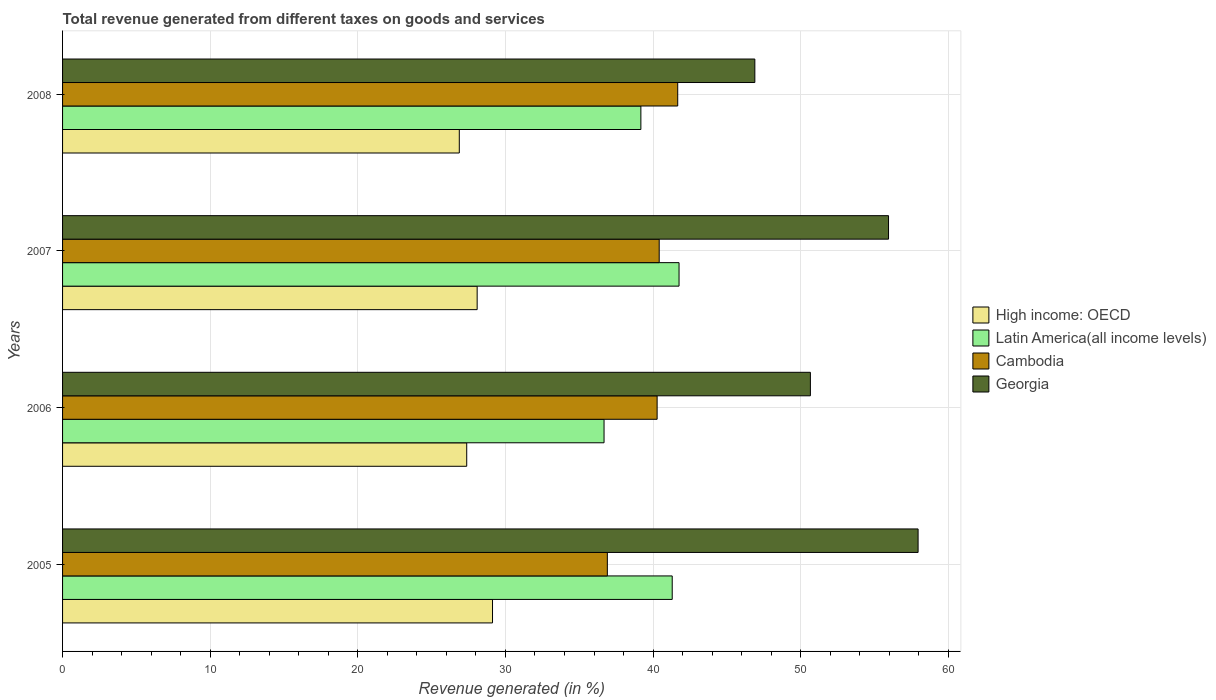How many groups of bars are there?
Provide a short and direct response. 4. Are the number of bars per tick equal to the number of legend labels?
Provide a short and direct response. Yes. Are the number of bars on each tick of the Y-axis equal?
Make the answer very short. Yes. How many bars are there on the 2nd tick from the top?
Offer a very short reply. 4. How many bars are there on the 4th tick from the bottom?
Offer a very short reply. 4. What is the total revenue generated in Latin America(all income levels) in 2007?
Make the answer very short. 41.76. Across all years, what is the maximum total revenue generated in Georgia?
Provide a succinct answer. 57.95. Across all years, what is the minimum total revenue generated in Latin America(all income levels)?
Your answer should be very brief. 36.68. In which year was the total revenue generated in Cambodia minimum?
Make the answer very short. 2005. What is the total total revenue generated in Latin America(all income levels) in the graph?
Make the answer very short. 158.91. What is the difference between the total revenue generated in Latin America(all income levels) in 2007 and that in 2008?
Your answer should be very brief. 2.59. What is the difference between the total revenue generated in Cambodia in 2006 and the total revenue generated in Latin America(all income levels) in 2005?
Provide a short and direct response. -1.02. What is the average total revenue generated in Latin America(all income levels) per year?
Ensure brevity in your answer.  39.73. In the year 2008, what is the difference between the total revenue generated in Georgia and total revenue generated in Cambodia?
Ensure brevity in your answer.  5.22. What is the ratio of the total revenue generated in High income: OECD in 2006 to that in 2007?
Provide a short and direct response. 0.97. Is the difference between the total revenue generated in Georgia in 2005 and 2006 greater than the difference between the total revenue generated in Cambodia in 2005 and 2006?
Give a very brief answer. Yes. What is the difference between the highest and the second highest total revenue generated in Cambodia?
Keep it short and to the point. 1.25. What is the difference between the highest and the lowest total revenue generated in High income: OECD?
Provide a succinct answer. 2.25. In how many years, is the total revenue generated in High income: OECD greater than the average total revenue generated in High income: OECD taken over all years?
Ensure brevity in your answer.  2. What does the 2nd bar from the top in 2006 represents?
Your answer should be compact. Cambodia. What does the 4th bar from the bottom in 2008 represents?
Your answer should be compact. Georgia. Are all the bars in the graph horizontal?
Give a very brief answer. Yes. Are the values on the major ticks of X-axis written in scientific E-notation?
Your answer should be very brief. No. Does the graph contain any zero values?
Ensure brevity in your answer.  No. Does the graph contain grids?
Your answer should be compact. Yes. How are the legend labels stacked?
Provide a succinct answer. Vertical. What is the title of the graph?
Provide a succinct answer. Total revenue generated from different taxes on goods and services. What is the label or title of the X-axis?
Offer a very short reply. Revenue generated (in %). What is the label or title of the Y-axis?
Provide a short and direct response. Years. What is the Revenue generated (in %) in High income: OECD in 2005?
Offer a terse response. 29.13. What is the Revenue generated (in %) in Latin America(all income levels) in 2005?
Give a very brief answer. 41.3. What is the Revenue generated (in %) in Cambodia in 2005?
Provide a succinct answer. 36.9. What is the Revenue generated (in %) in Georgia in 2005?
Offer a terse response. 57.95. What is the Revenue generated (in %) of High income: OECD in 2006?
Give a very brief answer. 27.38. What is the Revenue generated (in %) in Latin America(all income levels) in 2006?
Provide a succinct answer. 36.68. What is the Revenue generated (in %) in Cambodia in 2006?
Your response must be concise. 40.28. What is the Revenue generated (in %) of Georgia in 2006?
Give a very brief answer. 50.66. What is the Revenue generated (in %) of High income: OECD in 2007?
Make the answer very short. 28.08. What is the Revenue generated (in %) in Latin America(all income levels) in 2007?
Your answer should be compact. 41.76. What is the Revenue generated (in %) of Cambodia in 2007?
Ensure brevity in your answer.  40.42. What is the Revenue generated (in %) in Georgia in 2007?
Ensure brevity in your answer.  55.95. What is the Revenue generated (in %) in High income: OECD in 2008?
Ensure brevity in your answer.  26.87. What is the Revenue generated (in %) of Latin America(all income levels) in 2008?
Your response must be concise. 39.17. What is the Revenue generated (in %) in Cambodia in 2008?
Keep it short and to the point. 41.67. What is the Revenue generated (in %) in Georgia in 2008?
Ensure brevity in your answer.  46.89. Across all years, what is the maximum Revenue generated (in %) of High income: OECD?
Ensure brevity in your answer.  29.13. Across all years, what is the maximum Revenue generated (in %) in Latin America(all income levels)?
Provide a succinct answer. 41.76. Across all years, what is the maximum Revenue generated (in %) in Cambodia?
Keep it short and to the point. 41.67. Across all years, what is the maximum Revenue generated (in %) of Georgia?
Keep it short and to the point. 57.95. Across all years, what is the minimum Revenue generated (in %) in High income: OECD?
Keep it short and to the point. 26.87. Across all years, what is the minimum Revenue generated (in %) in Latin America(all income levels)?
Make the answer very short. 36.68. Across all years, what is the minimum Revenue generated (in %) in Cambodia?
Your answer should be compact. 36.9. Across all years, what is the minimum Revenue generated (in %) of Georgia?
Provide a short and direct response. 46.89. What is the total Revenue generated (in %) in High income: OECD in the graph?
Give a very brief answer. 111.46. What is the total Revenue generated (in %) in Latin America(all income levels) in the graph?
Your answer should be very brief. 158.91. What is the total Revenue generated (in %) of Cambodia in the graph?
Your answer should be compact. 159.27. What is the total Revenue generated (in %) of Georgia in the graph?
Offer a very short reply. 211.46. What is the difference between the Revenue generated (in %) of High income: OECD in 2005 and that in 2006?
Provide a short and direct response. 1.75. What is the difference between the Revenue generated (in %) in Latin America(all income levels) in 2005 and that in 2006?
Your answer should be very brief. 4.62. What is the difference between the Revenue generated (in %) of Cambodia in 2005 and that in 2006?
Ensure brevity in your answer.  -3.37. What is the difference between the Revenue generated (in %) in Georgia in 2005 and that in 2006?
Give a very brief answer. 7.3. What is the difference between the Revenue generated (in %) of High income: OECD in 2005 and that in 2007?
Ensure brevity in your answer.  1.04. What is the difference between the Revenue generated (in %) in Latin America(all income levels) in 2005 and that in 2007?
Offer a very short reply. -0.46. What is the difference between the Revenue generated (in %) of Cambodia in 2005 and that in 2007?
Ensure brevity in your answer.  -3.51. What is the difference between the Revenue generated (in %) in Georgia in 2005 and that in 2007?
Keep it short and to the point. 2. What is the difference between the Revenue generated (in %) of High income: OECD in 2005 and that in 2008?
Your answer should be very brief. 2.25. What is the difference between the Revenue generated (in %) in Latin America(all income levels) in 2005 and that in 2008?
Offer a very short reply. 2.12. What is the difference between the Revenue generated (in %) in Cambodia in 2005 and that in 2008?
Provide a short and direct response. -4.77. What is the difference between the Revenue generated (in %) of Georgia in 2005 and that in 2008?
Your answer should be compact. 11.06. What is the difference between the Revenue generated (in %) in High income: OECD in 2006 and that in 2007?
Your response must be concise. -0.71. What is the difference between the Revenue generated (in %) of Latin America(all income levels) in 2006 and that in 2007?
Ensure brevity in your answer.  -5.08. What is the difference between the Revenue generated (in %) of Cambodia in 2006 and that in 2007?
Keep it short and to the point. -0.14. What is the difference between the Revenue generated (in %) of Georgia in 2006 and that in 2007?
Ensure brevity in your answer.  -5.29. What is the difference between the Revenue generated (in %) in High income: OECD in 2006 and that in 2008?
Offer a very short reply. 0.5. What is the difference between the Revenue generated (in %) in Latin America(all income levels) in 2006 and that in 2008?
Offer a very short reply. -2.49. What is the difference between the Revenue generated (in %) of Cambodia in 2006 and that in 2008?
Ensure brevity in your answer.  -1.39. What is the difference between the Revenue generated (in %) in Georgia in 2006 and that in 2008?
Give a very brief answer. 3.76. What is the difference between the Revenue generated (in %) in High income: OECD in 2007 and that in 2008?
Provide a short and direct response. 1.21. What is the difference between the Revenue generated (in %) of Latin America(all income levels) in 2007 and that in 2008?
Give a very brief answer. 2.59. What is the difference between the Revenue generated (in %) in Cambodia in 2007 and that in 2008?
Offer a very short reply. -1.25. What is the difference between the Revenue generated (in %) of Georgia in 2007 and that in 2008?
Offer a very short reply. 9.06. What is the difference between the Revenue generated (in %) in High income: OECD in 2005 and the Revenue generated (in %) in Latin America(all income levels) in 2006?
Offer a very short reply. -7.56. What is the difference between the Revenue generated (in %) of High income: OECD in 2005 and the Revenue generated (in %) of Cambodia in 2006?
Offer a terse response. -11.15. What is the difference between the Revenue generated (in %) in High income: OECD in 2005 and the Revenue generated (in %) in Georgia in 2006?
Your response must be concise. -21.53. What is the difference between the Revenue generated (in %) in Latin America(all income levels) in 2005 and the Revenue generated (in %) in Cambodia in 2006?
Give a very brief answer. 1.02. What is the difference between the Revenue generated (in %) in Latin America(all income levels) in 2005 and the Revenue generated (in %) in Georgia in 2006?
Provide a succinct answer. -9.36. What is the difference between the Revenue generated (in %) of Cambodia in 2005 and the Revenue generated (in %) of Georgia in 2006?
Provide a short and direct response. -13.75. What is the difference between the Revenue generated (in %) of High income: OECD in 2005 and the Revenue generated (in %) of Latin America(all income levels) in 2007?
Provide a short and direct response. -12.64. What is the difference between the Revenue generated (in %) in High income: OECD in 2005 and the Revenue generated (in %) in Cambodia in 2007?
Provide a succinct answer. -11.29. What is the difference between the Revenue generated (in %) of High income: OECD in 2005 and the Revenue generated (in %) of Georgia in 2007?
Your answer should be very brief. -26.83. What is the difference between the Revenue generated (in %) in Latin America(all income levels) in 2005 and the Revenue generated (in %) in Cambodia in 2007?
Make the answer very short. 0.88. What is the difference between the Revenue generated (in %) of Latin America(all income levels) in 2005 and the Revenue generated (in %) of Georgia in 2007?
Your answer should be very brief. -14.65. What is the difference between the Revenue generated (in %) of Cambodia in 2005 and the Revenue generated (in %) of Georgia in 2007?
Keep it short and to the point. -19.05. What is the difference between the Revenue generated (in %) in High income: OECD in 2005 and the Revenue generated (in %) in Latin America(all income levels) in 2008?
Provide a short and direct response. -10.05. What is the difference between the Revenue generated (in %) of High income: OECD in 2005 and the Revenue generated (in %) of Cambodia in 2008?
Your response must be concise. -12.55. What is the difference between the Revenue generated (in %) of High income: OECD in 2005 and the Revenue generated (in %) of Georgia in 2008?
Your response must be concise. -17.77. What is the difference between the Revenue generated (in %) of Latin America(all income levels) in 2005 and the Revenue generated (in %) of Cambodia in 2008?
Keep it short and to the point. -0.37. What is the difference between the Revenue generated (in %) of Latin America(all income levels) in 2005 and the Revenue generated (in %) of Georgia in 2008?
Offer a very short reply. -5.6. What is the difference between the Revenue generated (in %) in Cambodia in 2005 and the Revenue generated (in %) in Georgia in 2008?
Make the answer very short. -9.99. What is the difference between the Revenue generated (in %) in High income: OECD in 2006 and the Revenue generated (in %) in Latin America(all income levels) in 2007?
Make the answer very short. -14.38. What is the difference between the Revenue generated (in %) of High income: OECD in 2006 and the Revenue generated (in %) of Cambodia in 2007?
Make the answer very short. -13.04. What is the difference between the Revenue generated (in %) in High income: OECD in 2006 and the Revenue generated (in %) in Georgia in 2007?
Offer a terse response. -28.57. What is the difference between the Revenue generated (in %) in Latin America(all income levels) in 2006 and the Revenue generated (in %) in Cambodia in 2007?
Your response must be concise. -3.74. What is the difference between the Revenue generated (in %) of Latin America(all income levels) in 2006 and the Revenue generated (in %) of Georgia in 2007?
Keep it short and to the point. -19.27. What is the difference between the Revenue generated (in %) of Cambodia in 2006 and the Revenue generated (in %) of Georgia in 2007?
Offer a terse response. -15.68. What is the difference between the Revenue generated (in %) in High income: OECD in 2006 and the Revenue generated (in %) in Latin America(all income levels) in 2008?
Your response must be concise. -11.8. What is the difference between the Revenue generated (in %) of High income: OECD in 2006 and the Revenue generated (in %) of Cambodia in 2008?
Provide a short and direct response. -14.29. What is the difference between the Revenue generated (in %) of High income: OECD in 2006 and the Revenue generated (in %) of Georgia in 2008?
Give a very brief answer. -19.52. What is the difference between the Revenue generated (in %) in Latin America(all income levels) in 2006 and the Revenue generated (in %) in Cambodia in 2008?
Give a very brief answer. -4.99. What is the difference between the Revenue generated (in %) of Latin America(all income levels) in 2006 and the Revenue generated (in %) of Georgia in 2008?
Provide a succinct answer. -10.21. What is the difference between the Revenue generated (in %) in Cambodia in 2006 and the Revenue generated (in %) in Georgia in 2008?
Offer a terse response. -6.62. What is the difference between the Revenue generated (in %) of High income: OECD in 2007 and the Revenue generated (in %) of Latin America(all income levels) in 2008?
Provide a short and direct response. -11.09. What is the difference between the Revenue generated (in %) in High income: OECD in 2007 and the Revenue generated (in %) in Cambodia in 2008?
Provide a short and direct response. -13.59. What is the difference between the Revenue generated (in %) of High income: OECD in 2007 and the Revenue generated (in %) of Georgia in 2008?
Give a very brief answer. -18.81. What is the difference between the Revenue generated (in %) in Latin America(all income levels) in 2007 and the Revenue generated (in %) in Cambodia in 2008?
Offer a very short reply. 0.09. What is the difference between the Revenue generated (in %) of Latin America(all income levels) in 2007 and the Revenue generated (in %) of Georgia in 2008?
Provide a short and direct response. -5.13. What is the difference between the Revenue generated (in %) in Cambodia in 2007 and the Revenue generated (in %) in Georgia in 2008?
Make the answer very short. -6.48. What is the average Revenue generated (in %) of High income: OECD per year?
Ensure brevity in your answer.  27.87. What is the average Revenue generated (in %) in Latin America(all income levels) per year?
Your answer should be compact. 39.73. What is the average Revenue generated (in %) of Cambodia per year?
Offer a terse response. 39.82. What is the average Revenue generated (in %) in Georgia per year?
Make the answer very short. 52.86. In the year 2005, what is the difference between the Revenue generated (in %) in High income: OECD and Revenue generated (in %) in Latin America(all income levels)?
Your answer should be very brief. -12.17. In the year 2005, what is the difference between the Revenue generated (in %) of High income: OECD and Revenue generated (in %) of Cambodia?
Provide a short and direct response. -7.78. In the year 2005, what is the difference between the Revenue generated (in %) in High income: OECD and Revenue generated (in %) in Georgia?
Make the answer very short. -28.83. In the year 2005, what is the difference between the Revenue generated (in %) in Latin America(all income levels) and Revenue generated (in %) in Cambodia?
Keep it short and to the point. 4.39. In the year 2005, what is the difference between the Revenue generated (in %) in Latin America(all income levels) and Revenue generated (in %) in Georgia?
Make the answer very short. -16.66. In the year 2005, what is the difference between the Revenue generated (in %) in Cambodia and Revenue generated (in %) in Georgia?
Offer a terse response. -21.05. In the year 2006, what is the difference between the Revenue generated (in %) of High income: OECD and Revenue generated (in %) of Latin America(all income levels)?
Offer a terse response. -9.3. In the year 2006, what is the difference between the Revenue generated (in %) of High income: OECD and Revenue generated (in %) of Cambodia?
Keep it short and to the point. -12.9. In the year 2006, what is the difference between the Revenue generated (in %) in High income: OECD and Revenue generated (in %) in Georgia?
Provide a succinct answer. -23.28. In the year 2006, what is the difference between the Revenue generated (in %) of Latin America(all income levels) and Revenue generated (in %) of Cambodia?
Ensure brevity in your answer.  -3.6. In the year 2006, what is the difference between the Revenue generated (in %) in Latin America(all income levels) and Revenue generated (in %) in Georgia?
Keep it short and to the point. -13.98. In the year 2006, what is the difference between the Revenue generated (in %) of Cambodia and Revenue generated (in %) of Georgia?
Provide a short and direct response. -10.38. In the year 2007, what is the difference between the Revenue generated (in %) of High income: OECD and Revenue generated (in %) of Latin America(all income levels)?
Ensure brevity in your answer.  -13.68. In the year 2007, what is the difference between the Revenue generated (in %) of High income: OECD and Revenue generated (in %) of Cambodia?
Your response must be concise. -12.33. In the year 2007, what is the difference between the Revenue generated (in %) of High income: OECD and Revenue generated (in %) of Georgia?
Provide a short and direct response. -27.87. In the year 2007, what is the difference between the Revenue generated (in %) in Latin America(all income levels) and Revenue generated (in %) in Cambodia?
Your response must be concise. 1.34. In the year 2007, what is the difference between the Revenue generated (in %) in Latin America(all income levels) and Revenue generated (in %) in Georgia?
Provide a succinct answer. -14.19. In the year 2007, what is the difference between the Revenue generated (in %) in Cambodia and Revenue generated (in %) in Georgia?
Your answer should be compact. -15.53. In the year 2008, what is the difference between the Revenue generated (in %) in High income: OECD and Revenue generated (in %) in Latin America(all income levels)?
Ensure brevity in your answer.  -12.3. In the year 2008, what is the difference between the Revenue generated (in %) in High income: OECD and Revenue generated (in %) in Cambodia?
Keep it short and to the point. -14.8. In the year 2008, what is the difference between the Revenue generated (in %) of High income: OECD and Revenue generated (in %) of Georgia?
Your answer should be very brief. -20.02. In the year 2008, what is the difference between the Revenue generated (in %) in Latin America(all income levels) and Revenue generated (in %) in Cambodia?
Offer a terse response. -2.5. In the year 2008, what is the difference between the Revenue generated (in %) of Latin America(all income levels) and Revenue generated (in %) of Georgia?
Your answer should be compact. -7.72. In the year 2008, what is the difference between the Revenue generated (in %) in Cambodia and Revenue generated (in %) in Georgia?
Offer a very short reply. -5.22. What is the ratio of the Revenue generated (in %) of High income: OECD in 2005 to that in 2006?
Provide a succinct answer. 1.06. What is the ratio of the Revenue generated (in %) of Latin America(all income levels) in 2005 to that in 2006?
Give a very brief answer. 1.13. What is the ratio of the Revenue generated (in %) of Cambodia in 2005 to that in 2006?
Give a very brief answer. 0.92. What is the ratio of the Revenue generated (in %) of Georgia in 2005 to that in 2006?
Keep it short and to the point. 1.14. What is the ratio of the Revenue generated (in %) in High income: OECD in 2005 to that in 2007?
Your answer should be compact. 1.04. What is the ratio of the Revenue generated (in %) in Latin America(all income levels) in 2005 to that in 2007?
Make the answer very short. 0.99. What is the ratio of the Revenue generated (in %) of Cambodia in 2005 to that in 2007?
Offer a very short reply. 0.91. What is the ratio of the Revenue generated (in %) of Georgia in 2005 to that in 2007?
Give a very brief answer. 1.04. What is the ratio of the Revenue generated (in %) in High income: OECD in 2005 to that in 2008?
Provide a short and direct response. 1.08. What is the ratio of the Revenue generated (in %) in Latin America(all income levels) in 2005 to that in 2008?
Make the answer very short. 1.05. What is the ratio of the Revenue generated (in %) of Cambodia in 2005 to that in 2008?
Your answer should be compact. 0.89. What is the ratio of the Revenue generated (in %) of Georgia in 2005 to that in 2008?
Provide a succinct answer. 1.24. What is the ratio of the Revenue generated (in %) in High income: OECD in 2006 to that in 2007?
Your answer should be compact. 0.97. What is the ratio of the Revenue generated (in %) of Latin America(all income levels) in 2006 to that in 2007?
Offer a terse response. 0.88. What is the ratio of the Revenue generated (in %) of Cambodia in 2006 to that in 2007?
Offer a very short reply. 1. What is the ratio of the Revenue generated (in %) of Georgia in 2006 to that in 2007?
Your answer should be very brief. 0.91. What is the ratio of the Revenue generated (in %) in High income: OECD in 2006 to that in 2008?
Offer a terse response. 1.02. What is the ratio of the Revenue generated (in %) in Latin America(all income levels) in 2006 to that in 2008?
Make the answer very short. 0.94. What is the ratio of the Revenue generated (in %) in Cambodia in 2006 to that in 2008?
Offer a very short reply. 0.97. What is the ratio of the Revenue generated (in %) of Georgia in 2006 to that in 2008?
Your response must be concise. 1.08. What is the ratio of the Revenue generated (in %) of High income: OECD in 2007 to that in 2008?
Your answer should be compact. 1.04. What is the ratio of the Revenue generated (in %) of Latin America(all income levels) in 2007 to that in 2008?
Your response must be concise. 1.07. What is the ratio of the Revenue generated (in %) of Cambodia in 2007 to that in 2008?
Your answer should be compact. 0.97. What is the ratio of the Revenue generated (in %) in Georgia in 2007 to that in 2008?
Provide a short and direct response. 1.19. What is the difference between the highest and the second highest Revenue generated (in %) of High income: OECD?
Provide a succinct answer. 1.04. What is the difference between the highest and the second highest Revenue generated (in %) of Latin America(all income levels)?
Give a very brief answer. 0.46. What is the difference between the highest and the second highest Revenue generated (in %) of Cambodia?
Your answer should be very brief. 1.25. What is the difference between the highest and the second highest Revenue generated (in %) of Georgia?
Keep it short and to the point. 2. What is the difference between the highest and the lowest Revenue generated (in %) of High income: OECD?
Offer a very short reply. 2.25. What is the difference between the highest and the lowest Revenue generated (in %) of Latin America(all income levels)?
Your answer should be very brief. 5.08. What is the difference between the highest and the lowest Revenue generated (in %) of Cambodia?
Your answer should be very brief. 4.77. What is the difference between the highest and the lowest Revenue generated (in %) of Georgia?
Ensure brevity in your answer.  11.06. 